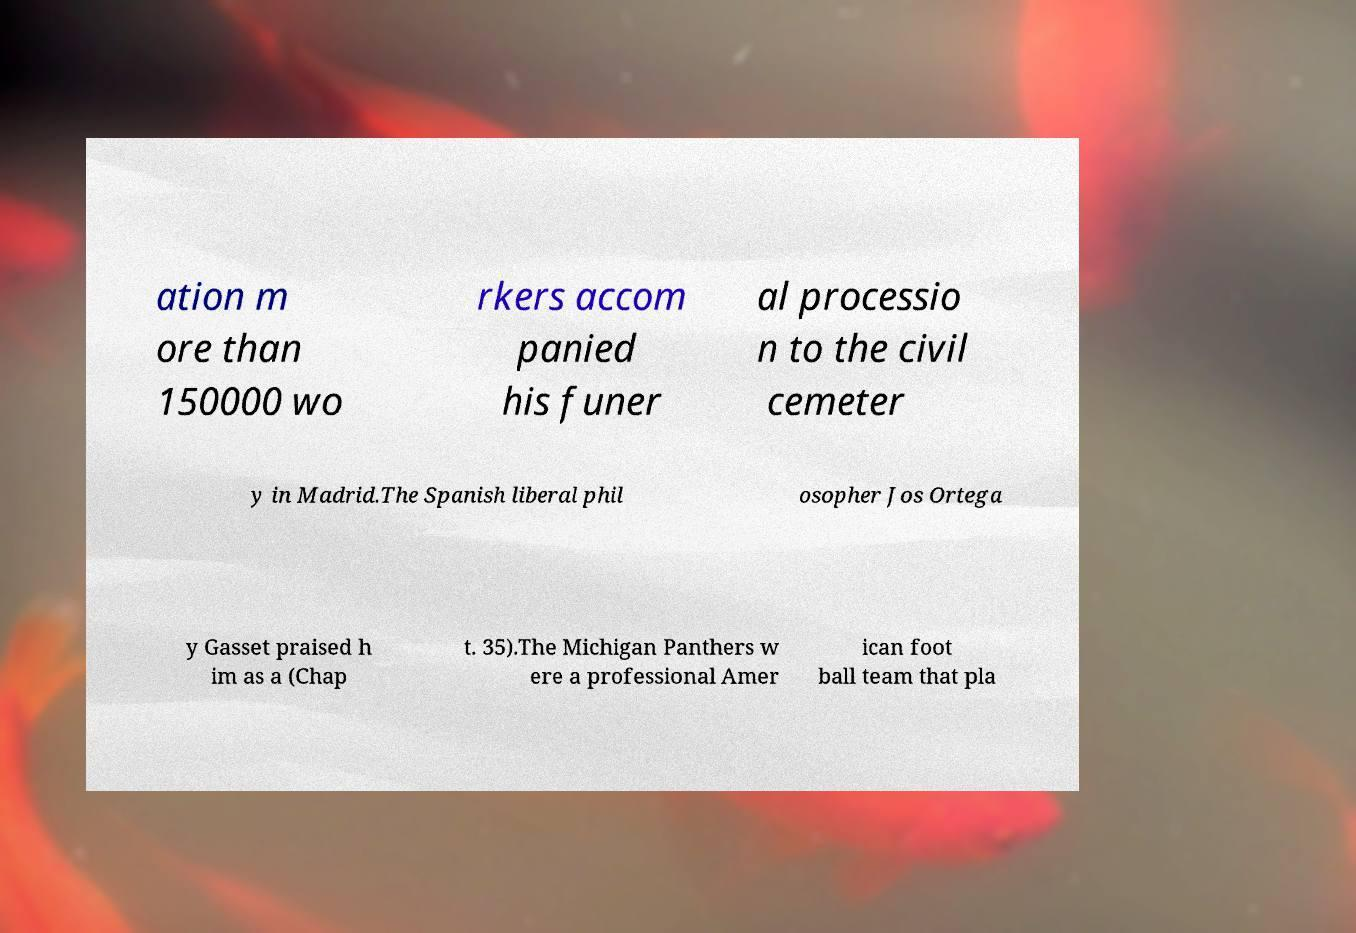What messages or text are displayed in this image? I need them in a readable, typed format. ation m ore than 150000 wo rkers accom panied his funer al processio n to the civil cemeter y in Madrid.The Spanish liberal phil osopher Jos Ortega y Gasset praised h im as a (Chap t. 35).The Michigan Panthers w ere a professional Amer ican foot ball team that pla 